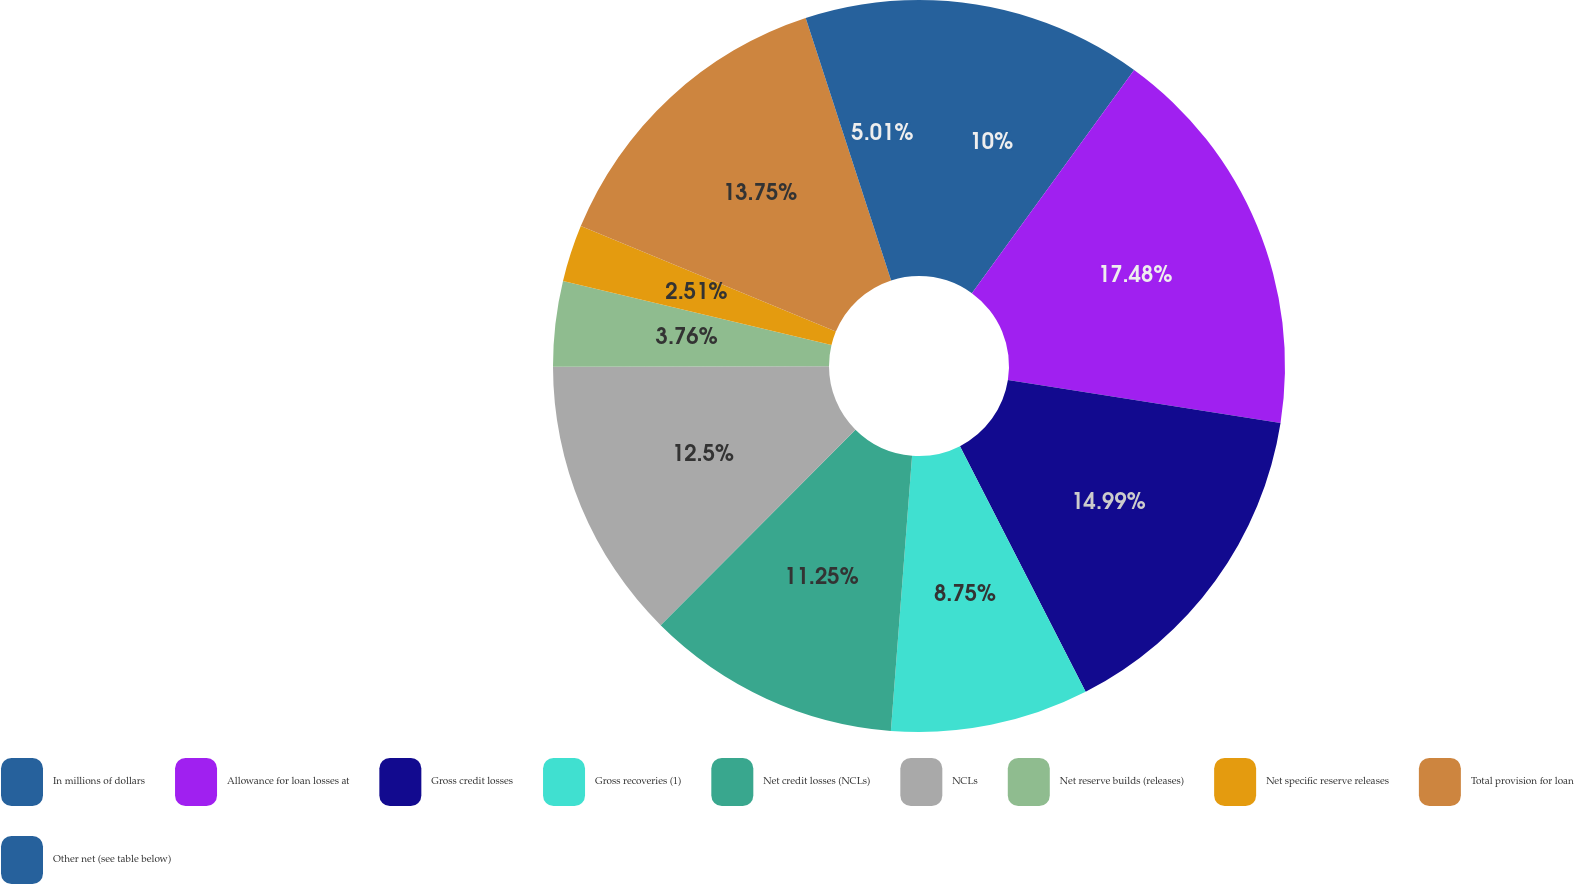<chart> <loc_0><loc_0><loc_500><loc_500><pie_chart><fcel>In millions of dollars<fcel>Allowance for loan losses at<fcel>Gross credit losses<fcel>Gross recoveries (1)<fcel>Net credit losses (NCLs)<fcel>NCLs<fcel>Net reserve builds (releases)<fcel>Net specific reserve releases<fcel>Total provision for loan<fcel>Other net (see table below)<nl><fcel>10.0%<fcel>17.49%<fcel>14.99%<fcel>8.75%<fcel>11.25%<fcel>12.5%<fcel>3.76%<fcel>2.51%<fcel>13.75%<fcel>5.01%<nl></chart> 